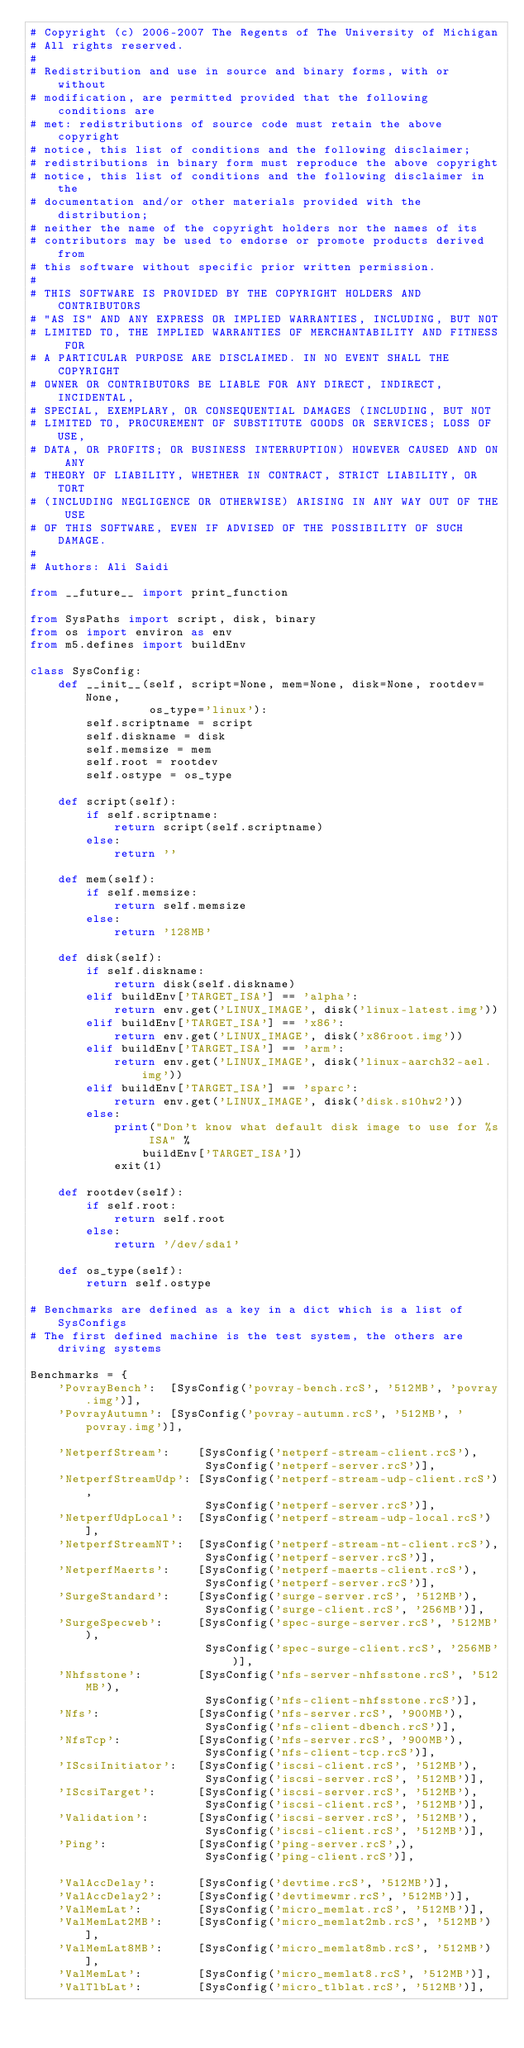Convert code to text. <code><loc_0><loc_0><loc_500><loc_500><_Python_># Copyright (c) 2006-2007 The Regents of The University of Michigan
# All rights reserved.
#
# Redistribution and use in source and binary forms, with or without
# modification, are permitted provided that the following conditions are
# met: redistributions of source code must retain the above copyright
# notice, this list of conditions and the following disclaimer;
# redistributions in binary form must reproduce the above copyright
# notice, this list of conditions and the following disclaimer in the
# documentation and/or other materials provided with the distribution;
# neither the name of the copyright holders nor the names of its
# contributors may be used to endorse or promote products derived from
# this software without specific prior written permission.
#
# THIS SOFTWARE IS PROVIDED BY THE COPYRIGHT HOLDERS AND CONTRIBUTORS
# "AS IS" AND ANY EXPRESS OR IMPLIED WARRANTIES, INCLUDING, BUT NOT
# LIMITED TO, THE IMPLIED WARRANTIES OF MERCHANTABILITY AND FITNESS FOR
# A PARTICULAR PURPOSE ARE DISCLAIMED. IN NO EVENT SHALL THE COPYRIGHT
# OWNER OR CONTRIBUTORS BE LIABLE FOR ANY DIRECT, INDIRECT, INCIDENTAL,
# SPECIAL, EXEMPLARY, OR CONSEQUENTIAL DAMAGES (INCLUDING, BUT NOT
# LIMITED TO, PROCUREMENT OF SUBSTITUTE GOODS OR SERVICES; LOSS OF USE,
# DATA, OR PROFITS; OR BUSINESS INTERRUPTION) HOWEVER CAUSED AND ON ANY
# THEORY OF LIABILITY, WHETHER IN CONTRACT, STRICT LIABILITY, OR TORT
# (INCLUDING NEGLIGENCE OR OTHERWISE) ARISING IN ANY WAY OUT OF THE USE
# OF THIS SOFTWARE, EVEN IF ADVISED OF THE POSSIBILITY OF SUCH DAMAGE.
#
# Authors: Ali Saidi

from __future__ import print_function

from SysPaths import script, disk, binary
from os import environ as env
from m5.defines import buildEnv

class SysConfig:
    def __init__(self, script=None, mem=None, disk=None, rootdev=None,
                 os_type='linux'):
        self.scriptname = script
        self.diskname = disk
        self.memsize = mem
        self.root = rootdev
        self.ostype = os_type

    def script(self):
        if self.scriptname:
            return script(self.scriptname)
        else:
            return ''

    def mem(self):
        if self.memsize:
            return self.memsize
        else:
            return '128MB'

    def disk(self):
        if self.diskname:
            return disk(self.diskname)
        elif buildEnv['TARGET_ISA'] == 'alpha':
            return env.get('LINUX_IMAGE', disk('linux-latest.img'))
        elif buildEnv['TARGET_ISA'] == 'x86':
            return env.get('LINUX_IMAGE', disk('x86root.img'))
        elif buildEnv['TARGET_ISA'] == 'arm':
            return env.get('LINUX_IMAGE', disk('linux-aarch32-ael.img'))
        elif buildEnv['TARGET_ISA'] == 'sparc':
            return env.get('LINUX_IMAGE', disk('disk.s10hw2'))
        else:
            print("Don't know what default disk image to use for %s ISA" %
                buildEnv['TARGET_ISA'])
            exit(1)

    def rootdev(self):
        if self.root:
            return self.root
        else:
            return '/dev/sda1'

    def os_type(self):
        return self.ostype

# Benchmarks are defined as a key in a dict which is a list of SysConfigs
# The first defined machine is the test system, the others are driving systems

Benchmarks = {
    'PovrayBench':  [SysConfig('povray-bench.rcS', '512MB', 'povray.img')],
    'PovrayAutumn': [SysConfig('povray-autumn.rcS', '512MB', 'povray.img')],

    'NetperfStream':    [SysConfig('netperf-stream-client.rcS'),
                         SysConfig('netperf-server.rcS')],
    'NetperfStreamUdp': [SysConfig('netperf-stream-udp-client.rcS'),
                         SysConfig('netperf-server.rcS')],
    'NetperfUdpLocal':  [SysConfig('netperf-stream-udp-local.rcS')],
    'NetperfStreamNT':  [SysConfig('netperf-stream-nt-client.rcS'),
                         SysConfig('netperf-server.rcS')],
    'NetperfMaerts':    [SysConfig('netperf-maerts-client.rcS'),
                         SysConfig('netperf-server.rcS')],
    'SurgeStandard':    [SysConfig('surge-server.rcS', '512MB'),
                         SysConfig('surge-client.rcS', '256MB')],
    'SurgeSpecweb':     [SysConfig('spec-surge-server.rcS', '512MB'),
                         SysConfig('spec-surge-client.rcS', '256MB')],
    'Nhfsstone':        [SysConfig('nfs-server-nhfsstone.rcS', '512MB'),
                         SysConfig('nfs-client-nhfsstone.rcS')],
    'Nfs':              [SysConfig('nfs-server.rcS', '900MB'),
                         SysConfig('nfs-client-dbench.rcS')],
    'NfsTcp':           [SysConfig('nfs-server.rcS', '900MB'),
                         SysConfig('nfs-client-tcp.rcS')],
    'IScsiInitiator':   [SysConfig('iscsi-client.rcS', '512MB'),
                         SysConfig('iscsi-server.rcS', '512MB')],
    'IScsiTarget':      [SysConfig('iscsi-server.rcS', '512MB'),
                         SysConfig('iscsi-client.rcS', '512MB')],
    'Validation':       [SysConfig('iscsi-server.rcS', '512MB'),
                         SysConfig('iscsi-client.rcS', '512MB')],
    'Ping':             [SysConfig('ping-server.rcS',),
                         SysConfig('ping-client.rcS')],

    'ValAccDelay':      [SysConfig('devtime.rcS', '512MB')],
    'ValAccDelay2':     [SysConfig('devtimewmr.rcS', '512MB')],
    'ValMemLat':        [SysConfig('micro_memlat.rcS', '512MB')],
    'ValMemLat2MB':     [SysConfig('micro_memlat2mb.rcS', '512MB')],
    'ValMemLat8MB':     [SysConfig('micro_memlat8mb.rcS', '512MB')],
    'ValMemLat':        [SysConfig('micro_memlat8.rcS', '512MB')],
    'ValTlbLat':        [SysConfig('micro_tlblat.rcS', '512MB')],</code> 